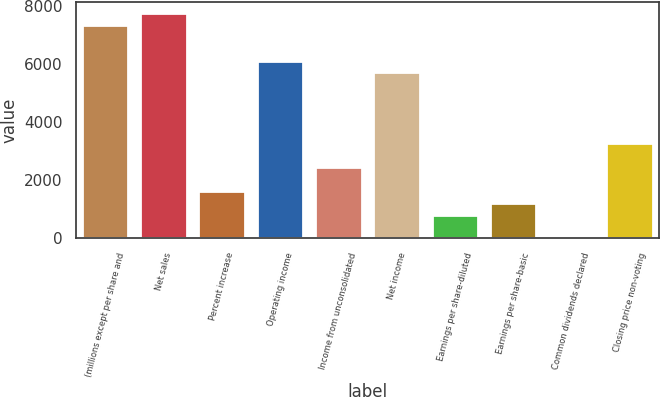<chart> <loc_0><loc_0><loc_500><loc_500><bar_chart><fcel>(millions except per share and<fcel>Net sales<fcel>Percent increase<fcel>Operating income<fcel>Income from unconsolidated<fcel>Net income<fcel>Earnings per share-diluted<fcel>Earnings per share-basic<fcel>Common dividends declared<fcel>Closing price non-voting<nl><fcel>7357.14<fcel>7765.81<fcel>1635.81<fcel>6131.14<fcel>2453.14<fcel>5722.48<fcel>818.48<fcel>1227.14<fcel>1.15<fcel>3270.47<nl></chart> 